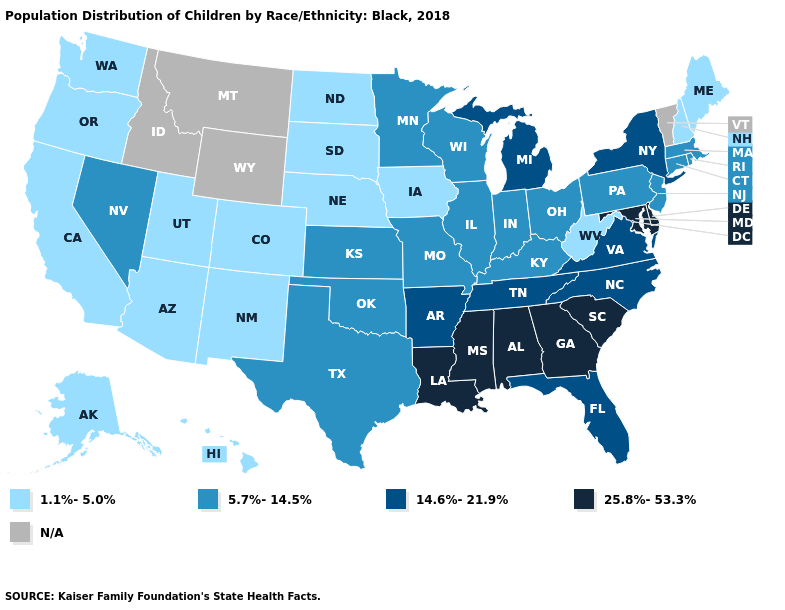Name the states that have a value in the range N/A?
Answer briefly. Idaho, Montana, Vermont, Wyoming. Which states have the lowest value in the USA?
Give a very brief answer. Alaska, Arizona, California, Colorado, Hawaii, Iowa, Maine, Nebraska, New Hampshire, New Mexico, North Dakota, Oregon, South Dakota, Utah, Washington, West Virginia. What is the lowest value in the USA?
Short answer required. 1.1%-5.0%. What is the lowest value in the MidWest?
Quick response, please. 1.1%-5.0%. Does the map have missing data?
Answer briefly. Yes. Among the states that border Iowa , which have the lowest value?
Give a very brief answer. Nebraska, South Dakota. What is the highest value in states that border Massachusetts?
Short answer required. 14.6%-21.9%. What is the value of West Virginia?
Be succinct. 1.1%-5.0%. Does Delaware have the lowest value in the USA?
Concise answer only. No. What is the lowest value in the MidWest?
Answer briefly. 1.1%-5.0%. Name the states that have a value in the range 5.7%-14.5%?
Keep it brief. Connecticut, Illinois, Indiana, Kansas, Kentucky, Massachusetts, Minnesota, Missouri, Nevada, New Jersey, Ohio, Oklahoma, Pennsylvania, Rhode Island, Texas, Wisconsin. Does the first symbol in the legend represent the smallest category?
Answer briefly. Yes. How many symbols are there in the legend?
Concise answer only. 5. What is the lowest value in the South?
Be succinct. 1.1%-5.0%. 